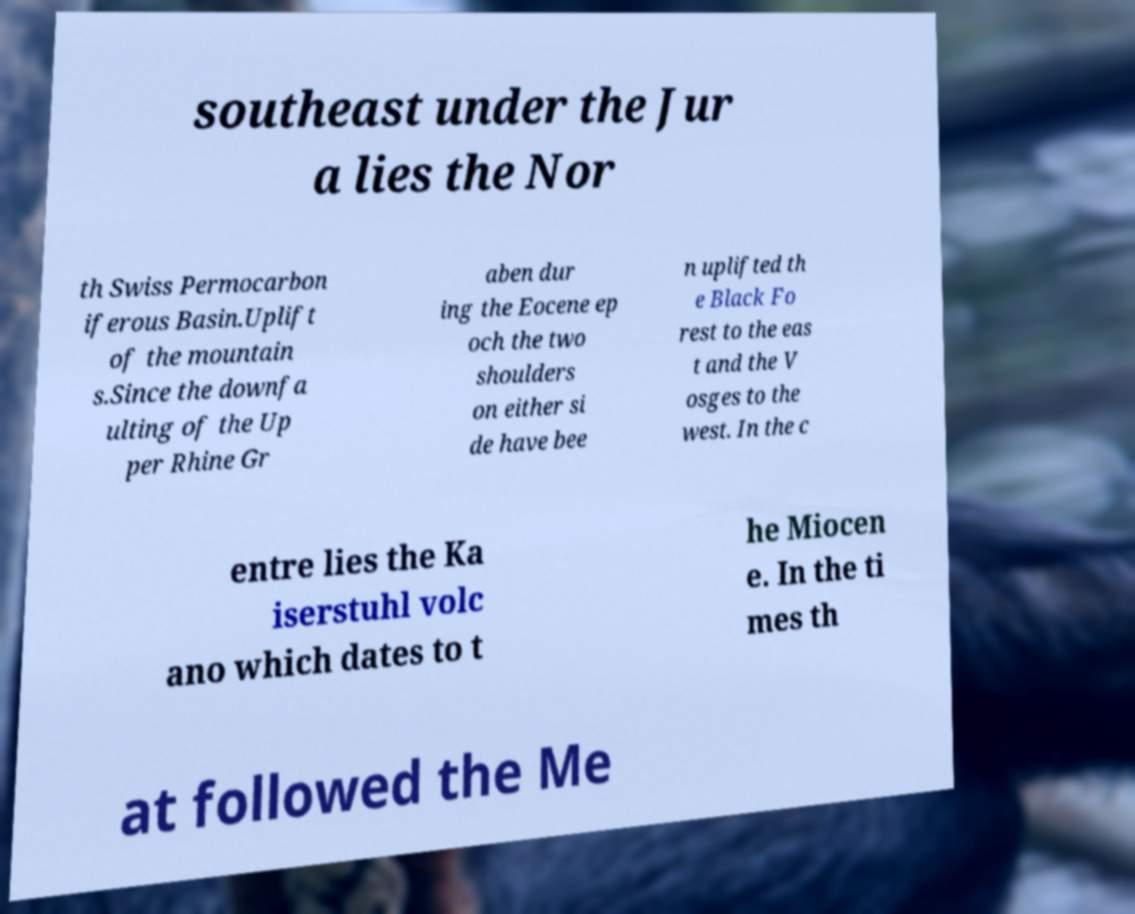I need the written content from this picture converted into text. Can you do that? southeast under the Jur a lies the Nor th Swiss Permocarbon iferous Basin.Uplift of the mountain s.Since the downfa ulting of the Up per Rhine Gr aben dur ing the Eocene ep och the two shoulders on either si de have bee n uplifted th e Black Fo rest to the eas t and the V osges to the west. In the c entre lies the Ka iserstuhl volc ano which dates to t he Miocen e. In the ti mes th at followed the Me 